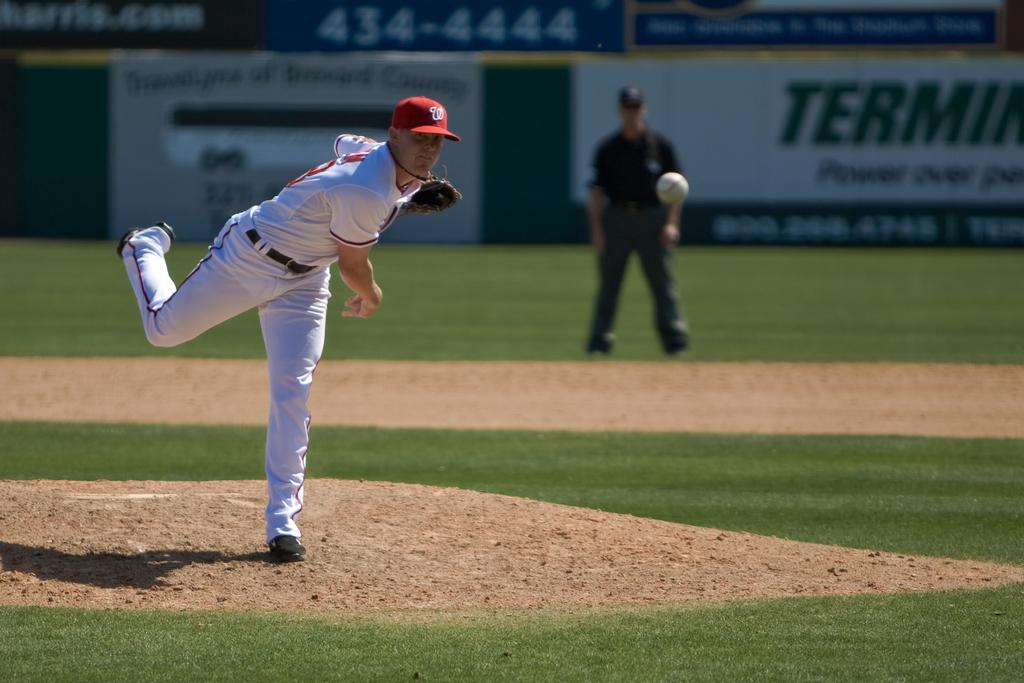What is the phone number in the background?
Provide a short and direct response. 434-4444. 